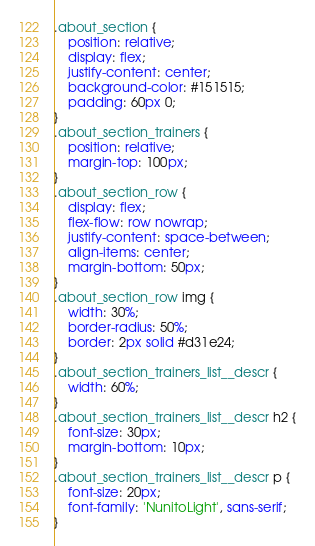<code> <loc_0><loc_0><loc_500><loc_500><_CSS_>.about_section {
    position: relative;
    display: flex;
    justify-content: center;
    background-color: #151515;
    padding: 60px 0;
}
.about_section_trainers {
    position: relative;
    margin-top: 100px;
}
.about_section_row {
    display: flex;
    flex-flow: row nowrap;
    justify-content: space-between;
    align-items: center;
    margin-bottom: 50px;
}
.about_section_row img {
    width: 30%;
    border-radius: 50%;
    border: 2px solid #d31e24;
}
.about_section_trainers_list__descr {
    width: 60%;
}
.about_section_trainers_list__descr h2 {
    font-size: 30px;
    margin-bottom: 10px;
}
.about_section_trainers_list__descr p {
    font-size: 20px;
    font-family: 'NunitoLight', sans-serif;
}</code> 